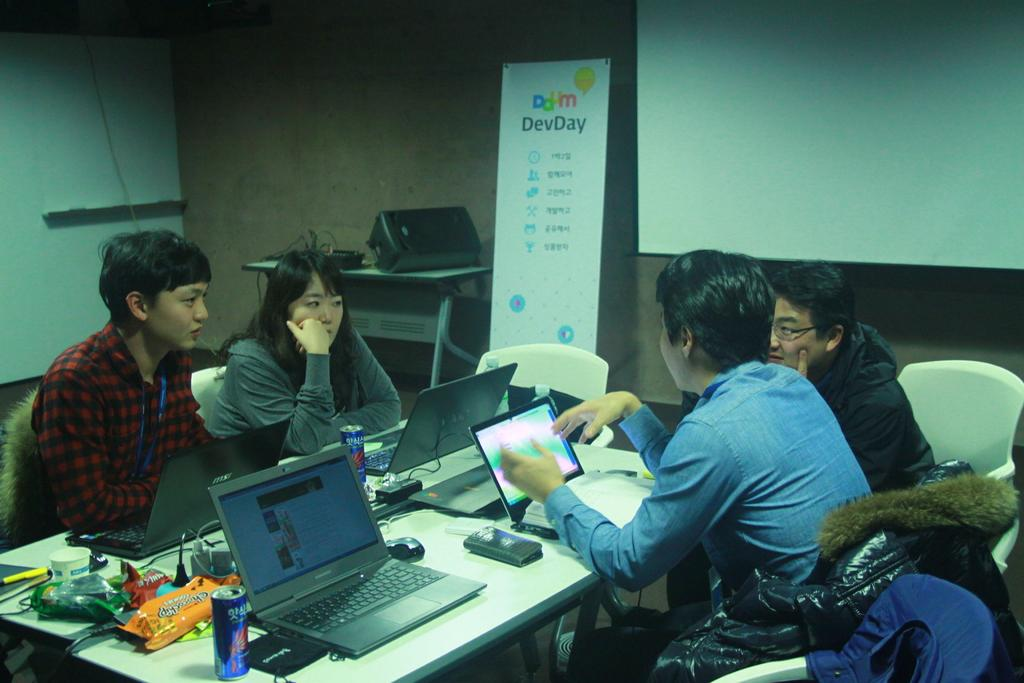<image>
Relay a brief, clear account of the picture shown. Four people sit around a table, and the large calendar agains the wall is entitled DevDay. 